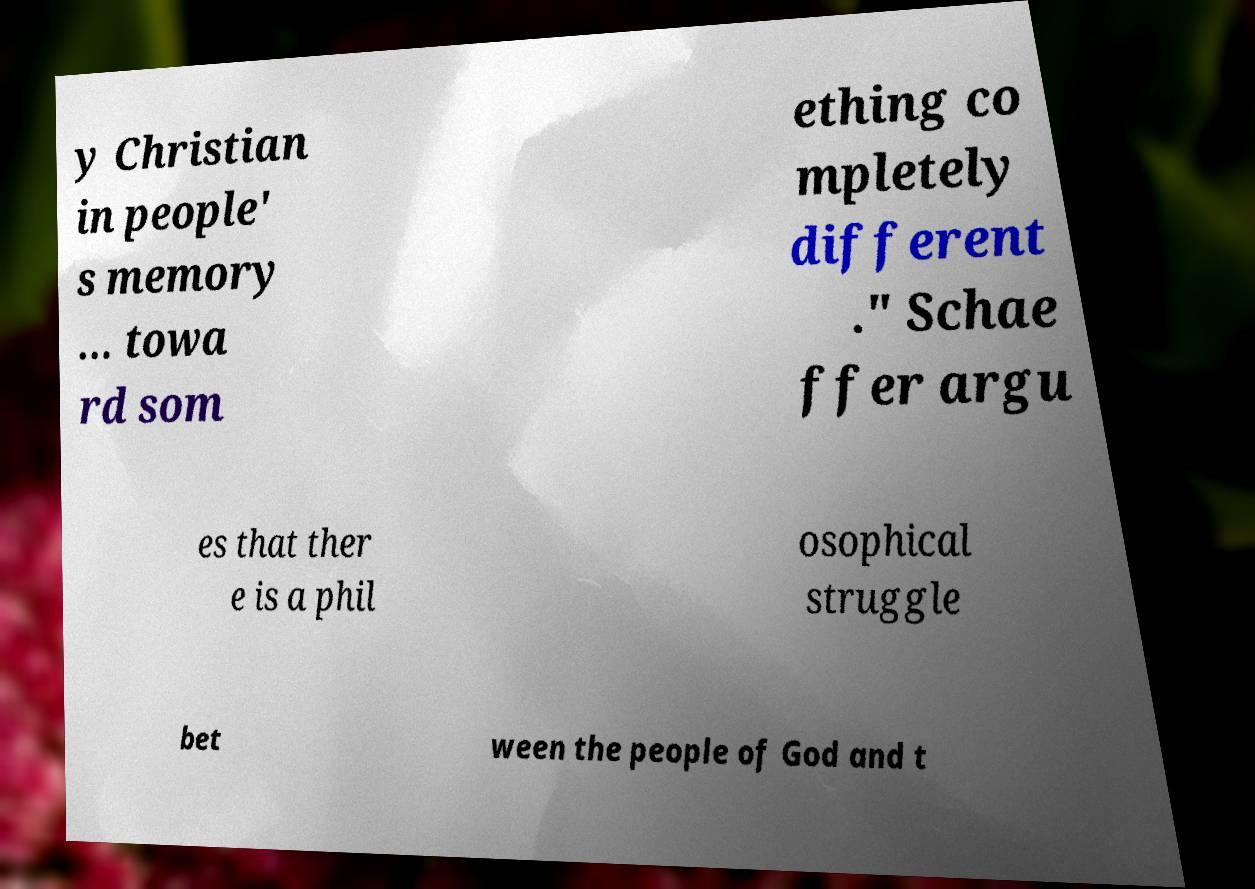Could you assist in decoding the text presented in this image and type it out clearly? y Christian in people' s memory … towa rd som ething co mpletely different ." Schae ffer argu es that ther e is a phil osophical struggle bet ween the people of God and t 